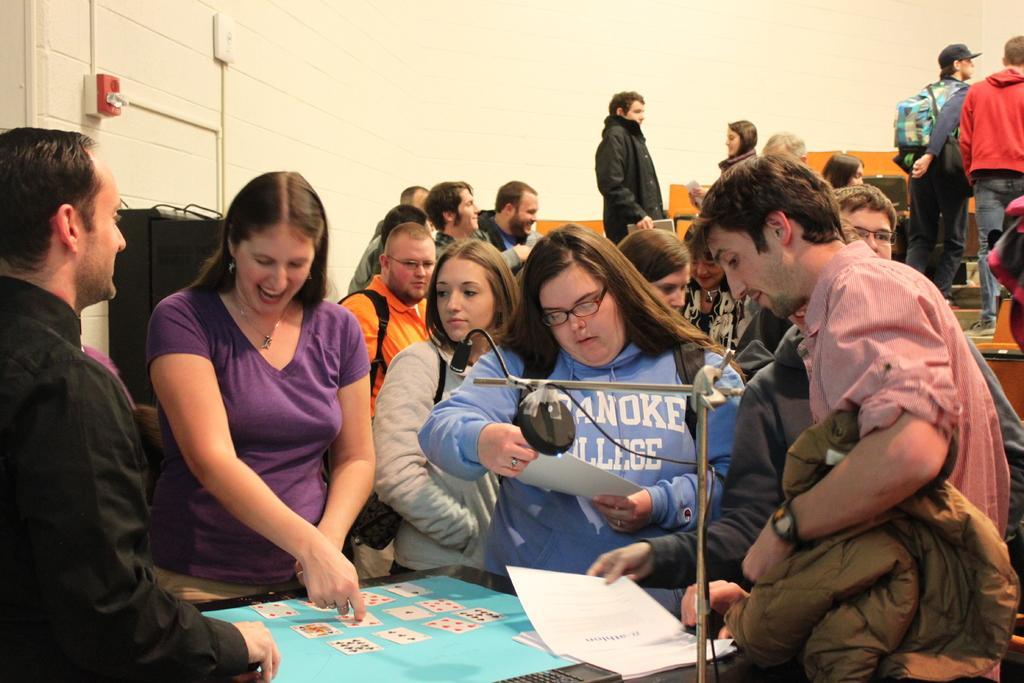In one or two sentences, can you explain what this image depicts? This image is taken indoors. In the background there is a wall and there is a switchboard. At the bottom of the image there is a table with a few cards and a few things on it. On the left side of the image there is a man. In the middle of the image a few people are standing. On the right side of the image a man is standing and he is holding a jacket in his hands. There are a few benches and a few people are standing. 